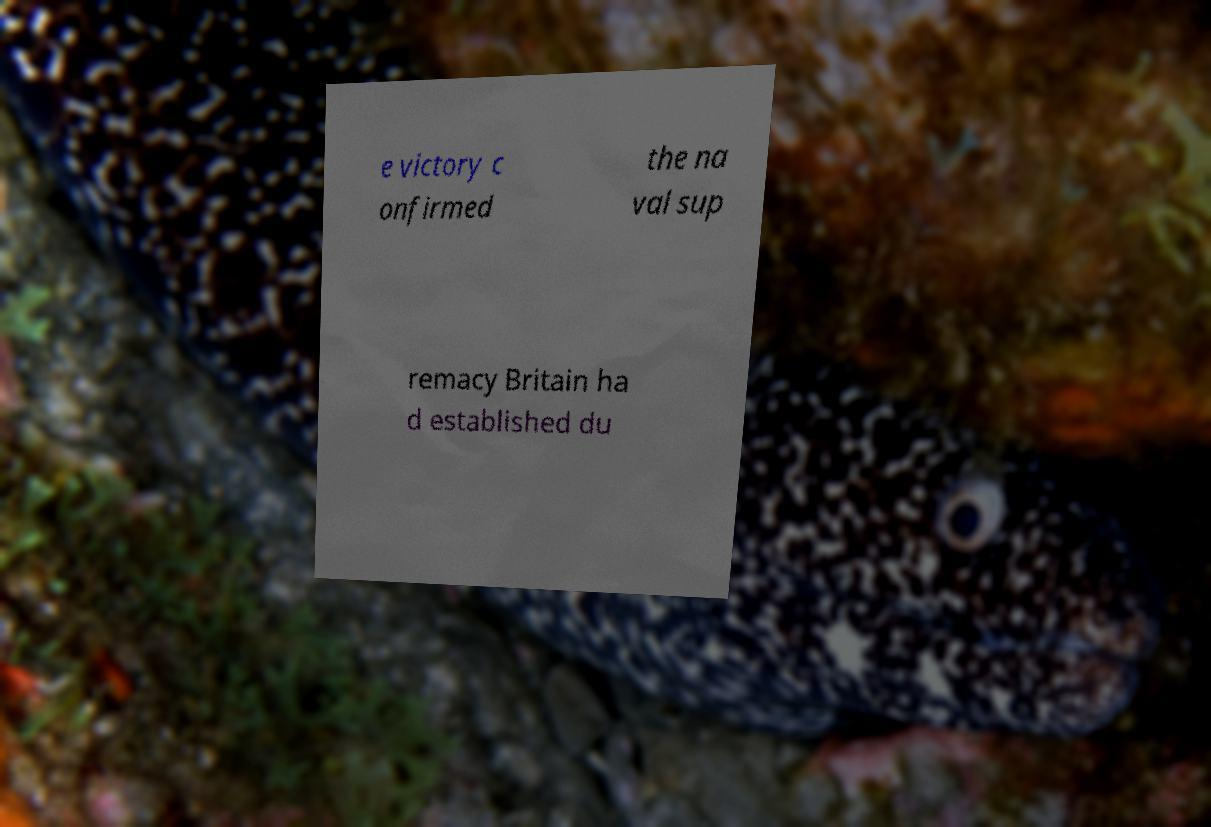Could you extract and type out the text from this image? e victory c onfirmed the na val sup remacy Britain ha d established du 